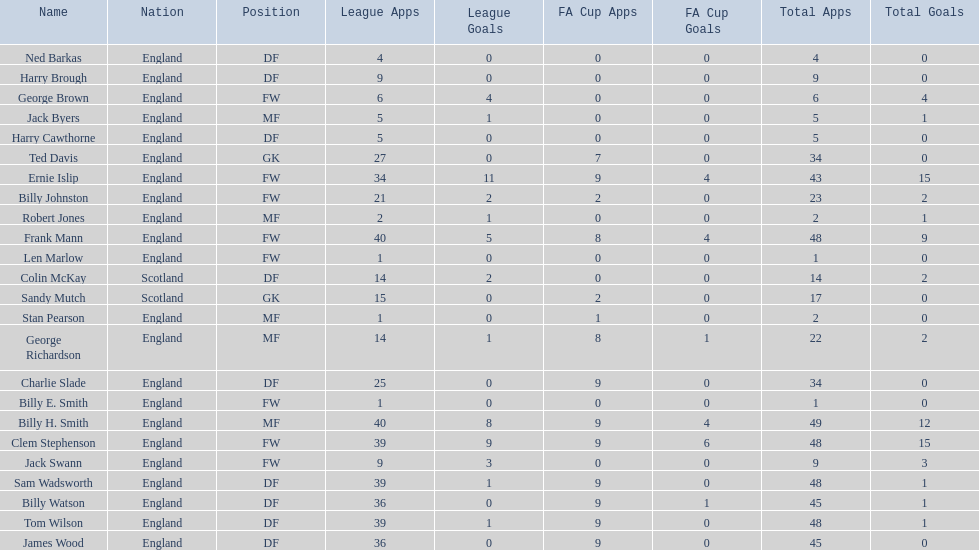Would you be able to parse every entry in this table? {'header': ['Name', 'Nation', 'Position', 'League Apps', 'League Goals', 'FA Cup Apps', 'FA Cup Goals', 'Total Apps', 'Total Goals'], 'rows': [['Ned Barkas', 'England', 'DF', '4', '0', '0', '0', '4', '0'], ['Harry Brough', 'England', 'DF', '9', '0', '0', '0', '9', '0'], ['George Brown', 'England', 'FW', '6', '4', '0', '0', '6', '4'], ['Jack Byers', 'England', 'MF', '5', '1', '0', '0', '5', '1'], ['Harry Cawthorne', 'England', 'DF', '5', '0', '0', '0', '5', '0'], ['Ted Davis', 'England', 'GK', '27', '0', '7', '0', '34', '0'], ['Ernie Islip', 'England', 'FW', '34', '11', '9', '4', '43', '15'], ['Billy Johnston', 'England', 'FW', '21', '2', '2', '0', '23', '2'], ['Robert Jones', 'England', 'MF', '2', '1', '0', '0', '2', '1'], ['Frank Mann', 'England', 'FW', '40', '5', '8', '4', '48', '9'], ['Len Marlow', 'England', 'FW', '1', '0', '0', '0', '1', '0'], ['Colin McKay', 'Scotland', 'DF', '14', '2', '0', '0', '14', '2'], ['Sandy Mutch', 'Scotland', 'GK', '15', '0', '2', '0', '17', '0'], ['Stan Pearson', 'England', 'MF', '1', '0', '1', '0', '2', '0'], ['George Richardson', 'England', 'MF', '14', '1', '8', '1', '22', '2'], ['Charlie Slade', 'England', 'DF', '25', '0', '9', '0', '34', '0'], ['Billy E. Smith', 'England', 'FW', '1', '0', '0', '0', '1', '0'], ['Billy H. Smith', 'England', 'MF', '40', '8', '9', '4', '49', '12'], ['Clem Stephenson', 'England', 'FW', '39', '9', '9', '6', '48', '15'], ['Jack Swann', 'England', 'FW', '9', '3', '0', '0', '9', '3'], ['Sam Wadsworth', 'England', 'DF', '39', '1', '9', '0', '48', '1'], ['Billy Watson', 'England', 'DF', '36', '0', '9', '1', '45', '1'], ['Tom Wilson', 'England', 'DF', '39', '1', '9', '0', '48', '1'], ['James Wood', 'England', 'DF', '36', '0', '9', '0', '45', '0']]} What is the mean quantity of scotland's overall applications? 15.5. 